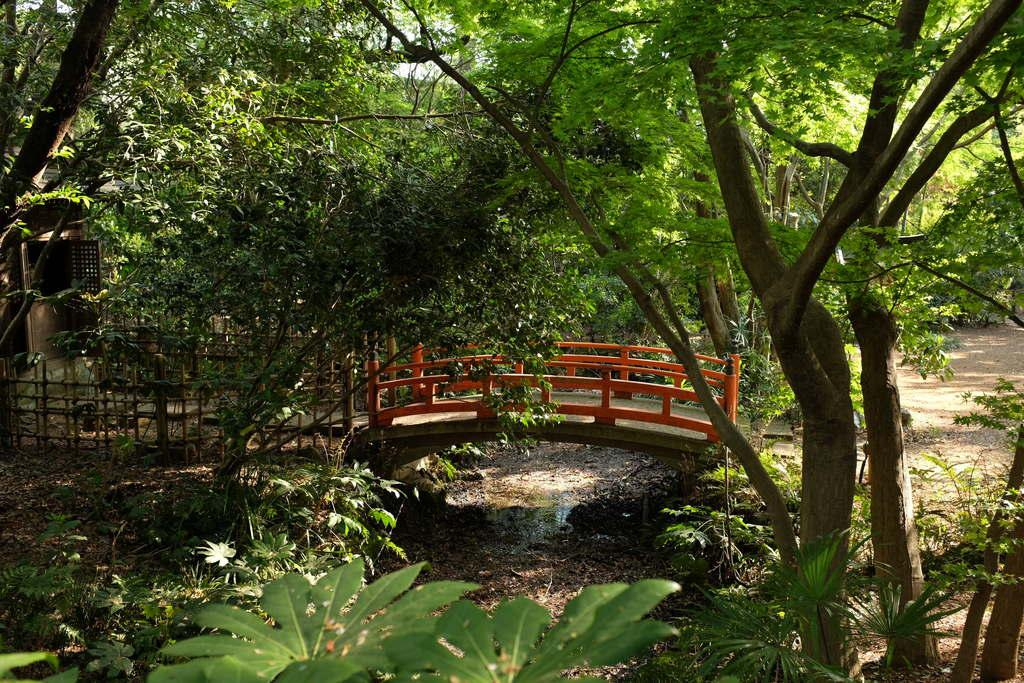What type of natural elements can be seen in the image? There are trees in the image. What man-made structure is present in the image? There is a bridge in the image. What is the surface on which the trees and bridge are situated? The ground is visible in the image. What type of barrier is present in the image? There is fencing in the image. What body of water can be seen in the image? There is water in the image. Where can the store receipt be found in the image? There is no store receipt present in the image. What type of polish is applied to the bridge in the image? There is no mention of polish being applied to the bridge in the image. 